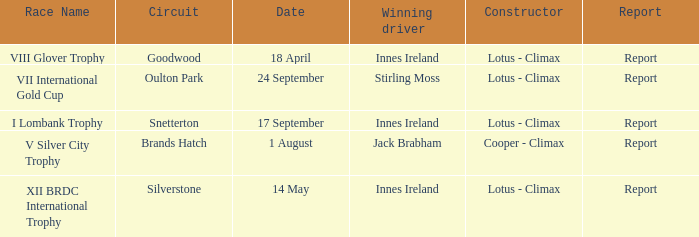What circuit did Innes Ireland win at for the I lombank trophy? Snetterton. 